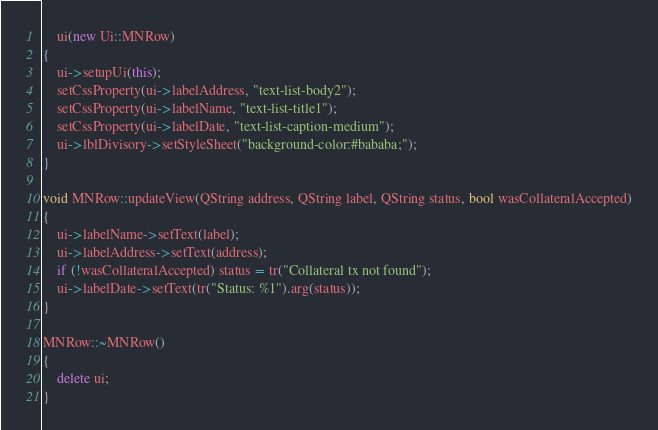Convert code to text. <code><loc_0><loc_0><loc_500><loc_500><_C++_>    ui(new Ui::MNRow)
{
    ui->setupUi(this);
    setCssProperty(ui->labelAddress, "text-list-body2");
    setCssProperty(ui->labelName, "text-list-title1");
    setCssProperty(ui->labelDate, "text-list-caption-medium");
    ui->lblDivisory->setStyleSheet("background-color:#bababa;");
}

void MNRow::updateView(QString address, QString label, QString status, bool wasCollateralAccepted)
{
    ui->labelName->setText(label);
    ui->labelAddress->setText(address);
    if (!wasCollateralAccepted) status = tr("Collateral tx not found");
    ui->labelDate->setText(tr("Status: %1").arg(status));
}

MNRow::~MNRow()
{
    delete ui;
}
</code> 